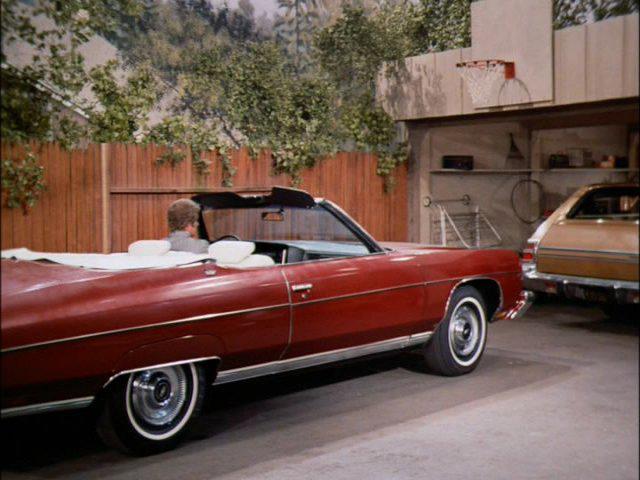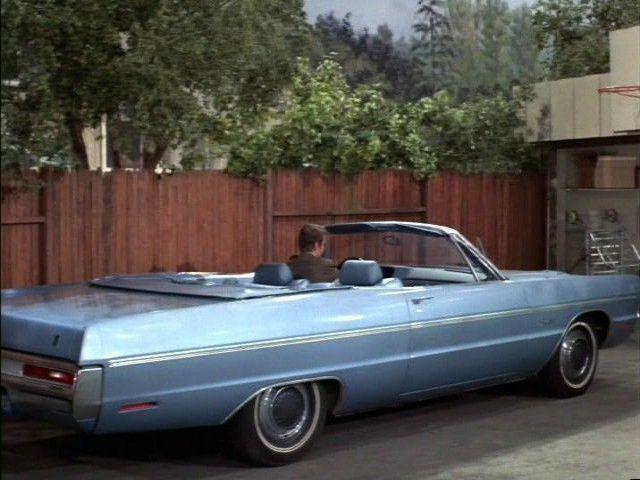The first image is the image on the left, the second image is the image on the right. Given the left and right images, does the statement "All of the cars in the images are sky blue." hold true? Answer yes or no. No. The first image is the image on the left, the second image is the image on the right. Given the left and right images, does the statement "Each image shows a person behind the wheel of a convertible." hold true? Answer yes or no. Yes. 